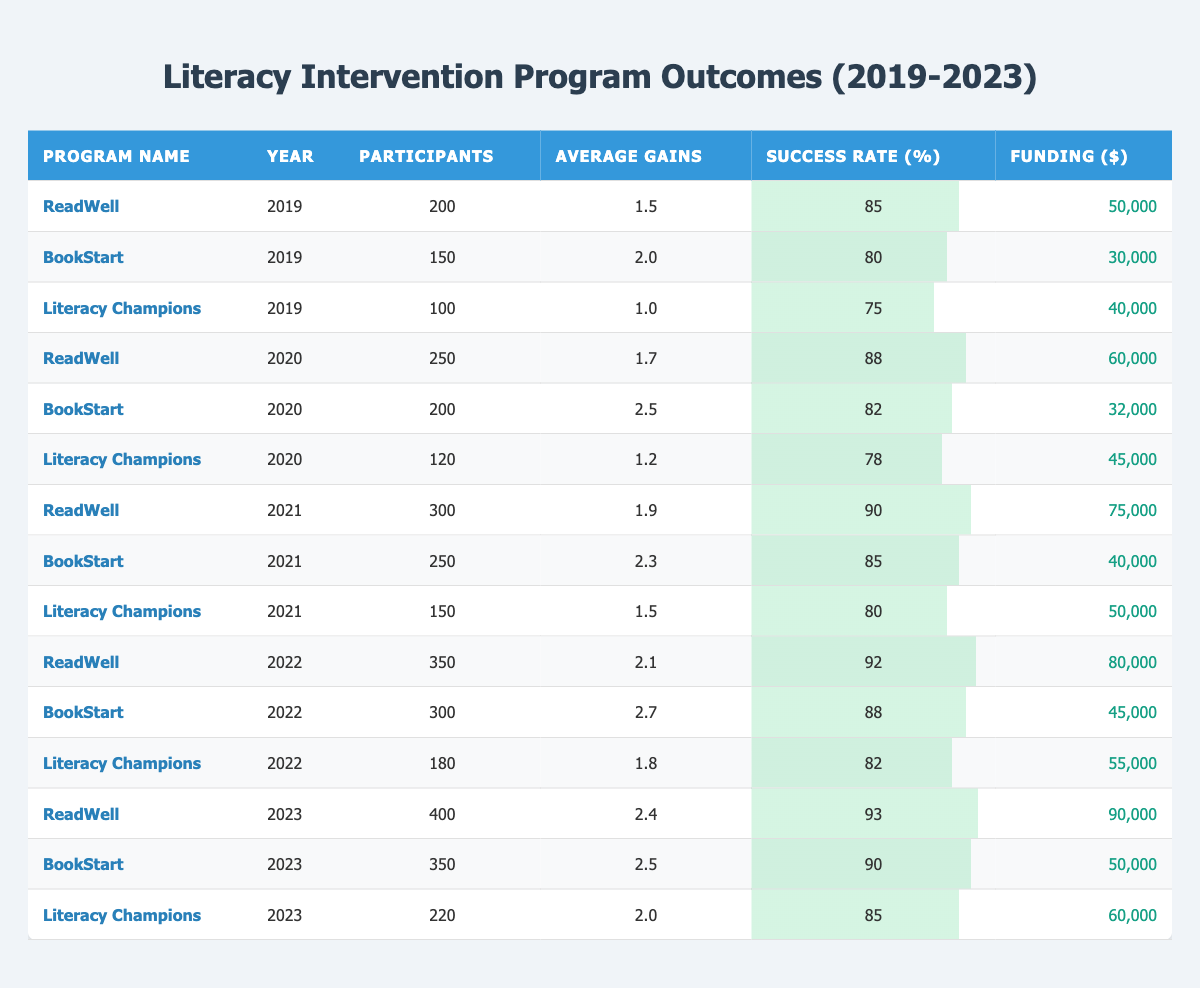What was the success rate of the BookStart program in 2022? The table lists the success rates for each program by year. Looking at the row for the BookStart program in 2022, the success rate is displayed as 88%.
Answer: 88% How many participants were involved in the Literacy Champions program in 2021? Referring to the specific row for the Literacy Champions program in 2021, it shows that there were 150 participants.
Answer: 150 Which program had the highest average gains in 2023? In the 2023 section of the table, we compare the average gains of the three programs: ReadWell (2.4), BookStart (2.5), and Literacy Champions (2.0). BookStart has the highest average gains at 2.5.
Answer: BookStart What is the total funding allocated to the ReadWell program from 2019 to 2023? We sum the funding for ReadWell across the years: 50000 (2019) + 60000 (2020) + 75000 (2021) + 80000 (2022) + 90000 (2023) = 375000. The total funding is 375000.
Answer: 375000 Did the success rate of the ReadWell program increase every year from 2019 to 2023? We check the success rates for ReadWell from each year: 2019 (85%), 2020 (88%), 2021 (90%), 2022 (92%), and 2023 (93%). Since the success rate continually increased each year, the answer is yes.
Answer: Yes What was the average number of participants across all programs in 2022? We consider the participants for all programs in 2022: ReadWell (350), BookStart (300), and Literacy Champions (180). The total is 350 + 300 + 180 = 830. There are three programs, so the average is 830 / 3 = 276.67.
Answer: 276.67 In 2020, which program had a higher success rate: BookStart or Literacy Champions? We compare the success rates for both programs in 2020: BookStart (82%) and Literacy Champions (78%). It is clear that BookStart had the higher success rate.
Answer: BookStart What was the overall trend in average gains for the ReadWell program from 2019 to 2023? We evaluate the average gains from 2019 (1.5), 2020 (1.7), 2021 (1.9), 2022 (2.1), and 2023 (2.4). The average gains increased consistently each year, indicating an upward trend.
Answer: Upward trend 